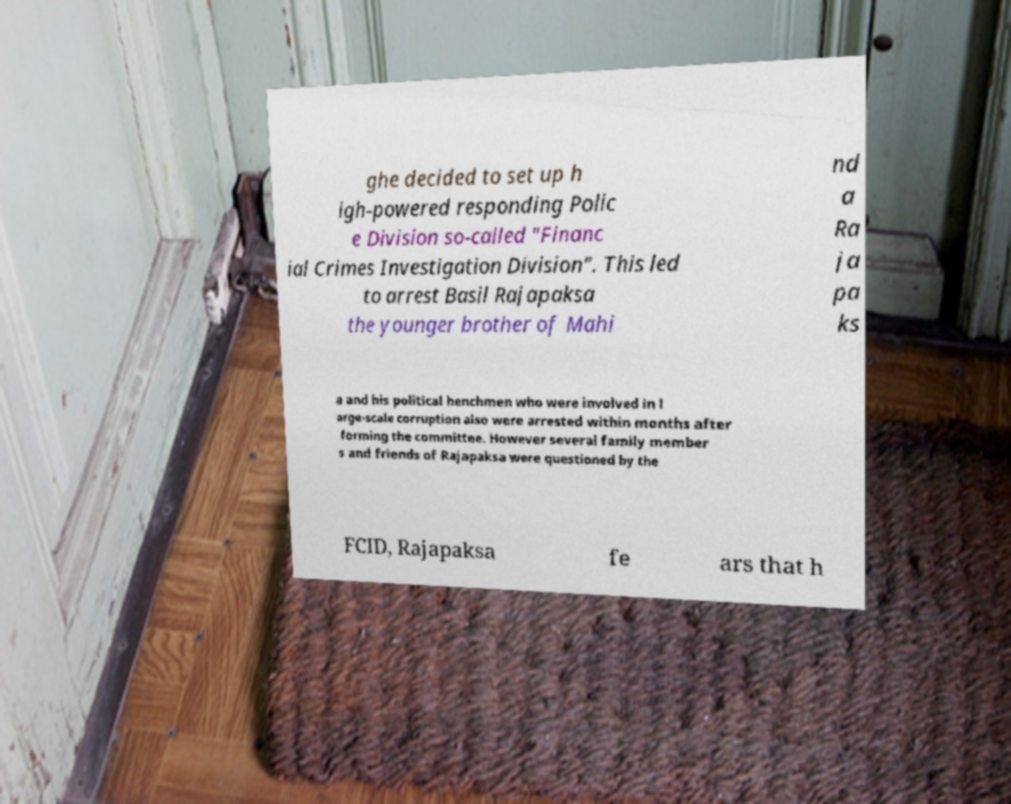Could you extract and type out the text from this image? ghe decided to set up h igh-powered responding Polic e Division so-called "Financ ial Crimes Investigation Division". This led to arrest Basil Rajapaksa the younger brother of Mahi nd a Ra ja pa ks a and his political henchmen who were involved in l arge-scale corruption also were arrested within months after forming the committee. However several family member s and friends of Rajapaksa were questioned by the FCID, Rajapaksa fe ars that h 